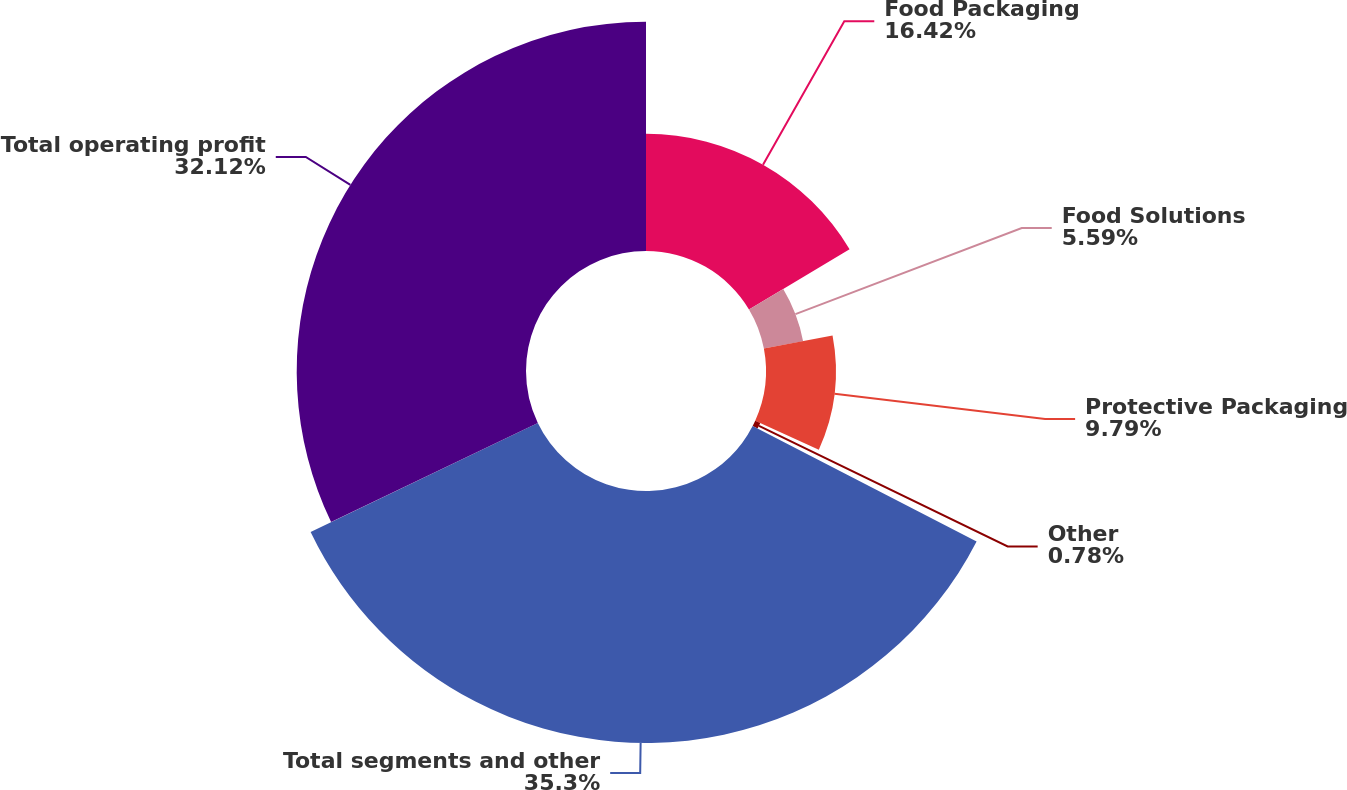Convert chart to OTSL. <chart><loc_0><loc_0><loc_500><loc_500><pie_chart><fcel>Food Packaging<fcel>Food Solutions<fcel>Protective Packaging<fcel>Other<fcel>Total segments and other<fcel>Total operating profit<nl><fcel>16.42%<fcel>5.59%<fcel>9.79%<fcel>0.78%<fcel>35.3%<fcel>32.12%<nl></chart> 